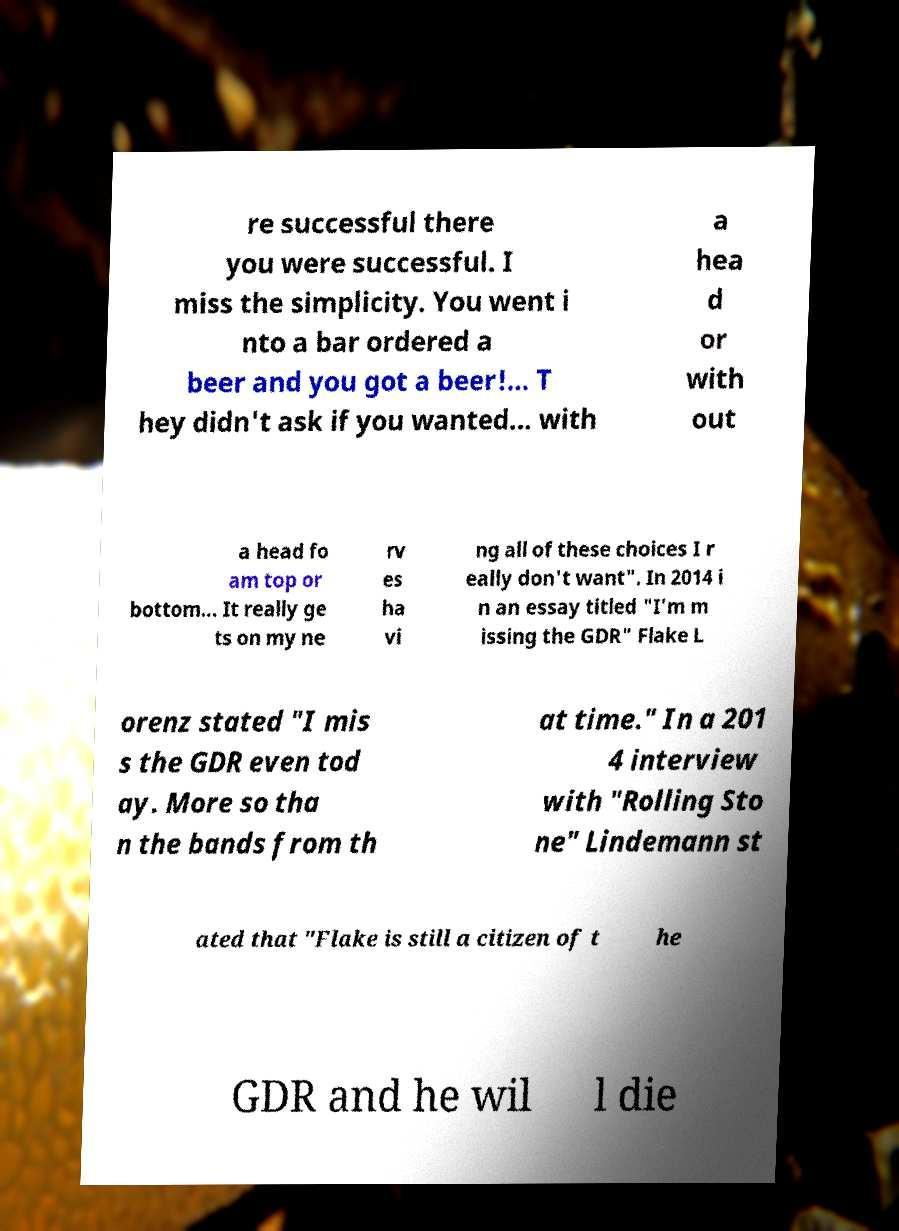There's text embedded in this image that I need extracted. Can you transcribe it verbatim? re successful there you were successful. I miss the simplicity. You went i nto a bar ordered a beer and you got a beer!... T hey didn't ask if you wanted... with a hea d or with out a head fo am top or bottom... It really ge ts on my ne rv es ha vi ng all of these choices I r eally don't want". In 2014 i n an essay titled "I'm m issing the GDR" Flake L orenz stated "I mis s the GDR even tod ay. More so tha n the bands from th at time." In a 201 4 interview with "Rolling Sto ne" Lindemann st ated that "Flake is still a citizen of t he GDR and he wil l die 